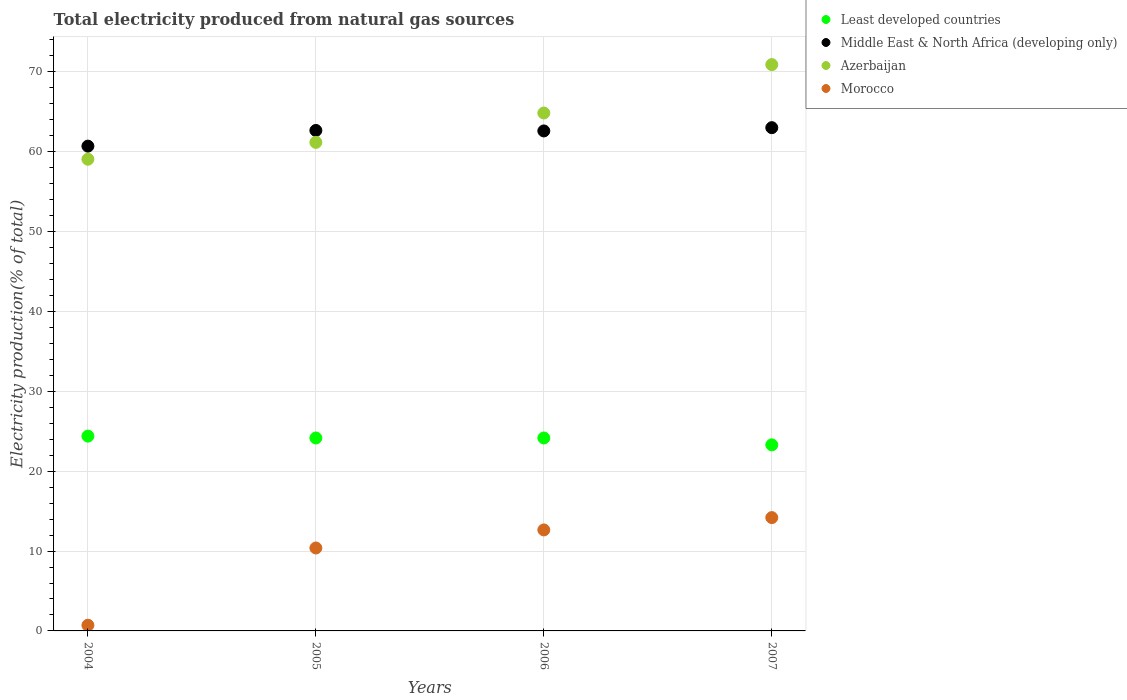What is the total electricity produced in Azerbaijan in 2007?
Keep it short and to the point. 70.91. Across all years, what is the maximum total electricity produced in Least developed countries?
Ensure brevity in your answer.  24.39. Across all years, what is the minimum total electricity produced in Middle East & North Africa (developing only)?
Ensure brevity in your answer.  60.7. In which year was the total electricity produced in Least developed countries maximum?
Offer a terse response. 2004. In which year was the total electricity produced in Morocco minimum?
Offer a terse response. 2004. What is the total total electricity produced in Azerbaijan in the graph?
Your answer should be very brief. 255.98. What is the difference between the total electricity produced in Azerbaijan in 2005 and that in 2006?
Your answer should be very brief. -3.67. What is the difference between the total electricity produced in Azerbaijan in 2006 and the total electricity produced in Least developed countries in 2005?
Provide a succinct answer. 40.69. What is the average total electricity produced in Middle East & North Africa (developing only) per year?
Your answer should be very brief. 62.24. In the year 2004, what is the difference between the total electricity produced in Least developed countries and total electricity produced in Morocco?
Ensure brevity in your answer.  23.68. In how many years, is the total electricity produced in Azerbaijan greater than 28 %?
Your answer should be compact. 4. What is the ratio of the total electricity produced in Middle East & North Africa (developing only) in 2004 to that in 2006?
Your response must be concise. 0.97. Is the total electricity produced in Morocco in 2005 less than that in 2006?
Offer a terse response. Yes. What is the difference between the highest and the second highest total electricity produced in Azerbaijan?
Give a very brief answer. 6.06. What is the difference between the highest and the lowest total electricity produced in Morocco?
Give a very brief answer. 13.48. In how many years, is the total electricity produced in Morocco greater than the average total electricity produced in Morocco taken over all years?
Make the answer very short. 3. Is the sum of the total electricity produced in Least developed countries in 2004 and 2007 greater than the maximum total electricity produced in Morocco across all years?
Your answer should be very brief. Yes. Is the total electricity produced in Morocco strictly greater than the total electricity produced in Azerbaijan over the years?
Offer a very short reply. No. What is the difference between two consecutive major ticks on the Y-axis?
Your answer should be compact. 10. Are the values on the major ticks of Y-axis written in scientific E-notation?
Your response must be concise. No. Does the graph contain grids?
Give a very brief answer. Yes. Where does the legend appear in the graph?
Ensure brevity in your answer.  Top right. What is the title of the graph?
Give a very brief answer. Total electricity produced from natural gas sources. What is the label or title of the X-axis?
Ensure brevity in your answer.  Years. What is the Electricity production(% of total) of Least developed countries in 2004?
Your answer should be compact. 24.39. What is the Electricity production(% of total) in Middle East & North Africa (developing only) in 2004?
Your answer should be compact. 60.7. What is the Electricity production(% of total) in Azerbaijan in 2004?
Make the answer very short. 59.06. What is the Electricity production(% of total) of Morocco in 2004?
Your answer should be very brief. 0.71. What is the Electricity production(% of total) in Least developed countries in 2005?
Ensure brevity in your answer.  24.16. What is the Electricity production(% of total) of Middle East & North Africa (developing only) in 2005?
Offer a terse response. 62.66. What is the Electricity production(% of total) of Azerbaijan in 2005?
Your response must be concise. 61.17. What is the Electricity production(% of total) of Morocco in 2005?
Provide a succinct answer. 10.38. What is the Electricity production(% of total) of Least developed countries in 2006?
Ensure brevity in your answer.  24.16. What is the Electricity production(% of total) in Middle East & North Africa (developing only) in 2006?
Your answer should be compact. 62.6. What is the Electricity production(% of total) in Azerbaijan in 2006?
Your answer should be compact. 64.85. What is the Electricity production(% of total) in Morocco in 2006?
Offer a very short reply. 12.65. What is the Electricity production(% of total) in Least developed countries in 2007?
Ensure brevity in your answer.  23.3. What is the Electricity production(% of total) in Middle East & North Africa (developing only) in 2007?
Your response must be concise. 63.01. What is the Electricity production(% of total) in Azerbaijan in 2007?
Ensure brevity in your answer.  70.91. What is the Electricity production(% of total) of Morocco in 2007?
Make the answer very short. 14.19. Across all years, what is the maximum Electricity production(% of total) of Least developed countries?
Your answer should be very brief. 24.39. Across all years, what is the maximum Electricity production(% of total) in Middle East & North Africa (developing only)?
Your answer should be very brief. 63.01. Across all years, what is the maximum Electricity production(% of total) of Azerbaijan?
Make the answer very short. 70.91. Across all years, what is the maximum Electricity production(% of total) in Morocco?
Your response must be concise. 14.19. Across all years, what is the minimum Electricity production(% of total) in Least developed countries?
Your answer should be compact. 23.3. Across all years, what is the minimum Electricity production(% of total) in Middle East & North Africa (developing only)?
Offer a very short reply. 60.7. Across all years, what is the minimum Electricity production(% of total) in Azerbaijan?
Offer a very short reply. 59.06. Across all years, what is the minimum Electricity production(% of total) in Morocco?
Make the answer very short. 0.71. What is the total Electricity production(% of total) of Least developed countries in the graph?
Ensure brevity in your answer.  96. What is the total Electricity production(% of total) in Middle East & North Africa (developing only) in the graph?
Keep it short and to the point. 248.97. What is the total Electricity production(% of total) in Azerbaijan in the graph?
Make the answer very short. 255.98. What is the total Electricity production(% of total) of Morocco in the graph?
Ensure brevity in your answer.  37.93. What is the difference between the Electricity production(% of total) in Least developed countries in 2004 and that in 2005?
Your response must be concise. 0.23. What is the difference between the Electricity production(% of total) of Middle East & North Africa (developing only) in 2004 and that in 2005?
Offer a terse response. -1.96. What is the difference between the Electricity production(% of total) of Azerbaijan in 2004 and that in 2005?
Provide a succinct answer. -2.11. What is the difference between the Electricity production(% of total) in Morocco in 2004 and that in 2005?
Ensure brevity in your answer.  -9.67. What is the difference between the Electricity production(% of total) of Least developed countries in 2004 and that in 2006?
Your answer should be very brief. 0.24. What is the difference between the Electricity production(% of total) in Middle East & North Africa (developing only) in 2004 and that in 2006?
Ensure brevity in your answer.  -1.9. What is the difference between the Electricity production(% of total) in Azerbaijan in 2004 and that in 2006?
Provide a succinct answer. -5.79. What is the difference between the Electricity production(% of total) of Morocco in 2004 and that in 2006?
Give a very brief answer. -11.93. What is the difference between the Electricity production(% of total) in Least developed countries in 2004 and that in 2007?
Provide a succinct answer. 1.1. What is the difference between the Electricity production(% of total) of Middle East & North Africa (developing only) in 2004 and that in 2007?
Your response must be concise. -2.31. What is the difference between the Electricity production(% of total) in Azerbaijan in 2004 and that in 2007?
Your response must be concise. -11.85. What is the difference between the Electricity production(% of total) of Morocco in 2004 and that in 2007?
Keep it short and to the point. -13.48. What is the difference between the Electricity production(% of total) of Least developed countries in 2005 and that in 2006?
Your response must be concise. 0. What is the difference between the Electricity production(% of total) of Middle East & North Africa (developing only) in 2005 and that in 2006?
Make the answer very short. 0.06. What is the difference between the Electricity production(% of total) in Azerbaijan in 2005 and that in 2006?
Offer a terse response. -3.67. What is the difference between the Electricity production(% of total) in Morocco in 2005 and that in 2006?
Your answer should be very brief. -2.26. What is the difference between the Electricity production(% of total) of Least developed countries in 2005 and that in 2007?
Provide a succinct answer. 0.86. What is the difference between the Electricity production(% of total) in Middle East & North Africa (developing only) in 2005 and that in 2007?
Offer a very short reply. -0.35. What is the difference between the Electricity production(% of total) in Azerbaijan in 2005 and that in 2007?
Offer a very short reply. -9.74. What is the difference between the Electricity production(% of total) of Morocco in 2005 and that in 2007?
Offer a terse response. -3.8. What is the difference between the Electricity production(% of total) of Least developed countries in 2006 and that in 2007?
Ensure brevity in your answer.  0.86. What is the difference between the Electricity production(% of total) in Middle East & North Africa (developing only) in 2006 and that in 2007?
Your response must be concise. -0.41. What is the difference between the Electricity production(% of total) in Azerbaijan in 2006 and that in 2007?
Provide a short and direct response. -6.06. What is the difference between the Electricity production(% of total) in Morocco in 2006 and that in 2007?
Offer a terse response. -1.54. What is the difference between the Electricity production(% of total) of Least developed countries in 2004 and the Electricity production(% of total) of Middle East & North Africa (developing only) in 2005?
Provide a succinct answer. -38.27. What is the difference between the Electricity production(% of total) in Least developed countries in 2004 and the Electricity production(% of total) in Azerbaijan in 2005?
Offer a very short reply. -36.78. What is the difference between the Electricity production(% of total) in Least developed countries in 2004 and the Electricity production(% of total) in Morocco in 2005?
Provide a short and direct response. 14.01. What is the difference between the Electricity production(% of total) of Middle East & North Africa (developing only) in 2004 and the Electricity production(% of total) of Azerbaijan in 2005?
Offer a very short reply. -0.47. What is the difference between the Electricity production(% of total) of Middle East & North Africa (developing only) in 2004 and the Electricity production(% of total) of Morocco in 2005?
Provide a short and direct response. 50.32. What is the difference between the Electricity production(% of total) of Azerbaijan in 2004 and the Electricity production(% of total) of Morocco in 2005?
Your answer should be compact. 48.68. What is the difference between the Electricity production(% of total) of Least developed countries in 2004 and the Electricity production(% of total) of Middle East & North Africa (developing only) in 2006?
Make the answer very short. -38.21. What is the difference between the Electricity production(% of total) in Least developed countries in 2004 and the Electricity production(% of total) in Azerbaijan in 2006?
Make the answer very short. -40.45. What is the difference between the Electricity production(% of total) in Least developed countries in 2004 and the Electricity production(% of total) in Morocco in 2006?
Offer a terse response. 11.75. What is the difference between the Electricity production(% of total) in Middle East & North Africa (developing only) in 2004 and the Electricity production(% of total) in Azerbaijan in 2006?
Offer a terse response. -4.15. What is the difference between the Electricity production(% of total) in Middle East & North Africa (developing only) in 2004 and the Electricity production(% of total) in Morocco in 2006?
Your answer should be very brief. 48.05. What is the difference between the Electricity production(% of total) in Azerbaijan in 2004 and the Electricity production(% of total) in Morocco in 2006?
Give a very brief answer. 46.41. What is the difference between the Electricity production(% of total) of Least developed countries in 2004 and the Electricity production(% of total) of Middle East & North Africa (developing only) in 2007?
Provide a succinct answer. -38.62. What is the difference between the Electricity production(% of total) in Least developed countries in 2004 and the Electricity production(% of total) in Azerbaijan in 2007?
Offer a very short reply. -46.51. What is the difference between the Electricity production(% of total) of Least developed countries in 2004 and the Electricity production(% of total) of Morocco in 2007?
Offer a very short reply. 10.2. What is the difference between the Electricity production(% of total) in Middle East & North Africa (developing only) in 2004 and the Electricity production(% of total) in Azerbaijan in 2007?
Keep it short and to the point. -10.21. What is the difference between the Electricity production(% of total) of Middle East & North Africa (developing only) in 2004 and the Electricity production(% of total) of Morocco in 2007?
Keep it short and to the point. 46.51. What is the difference between the Electricity production(% of total) of Azerbaijan in 2004 and the Electricity production(% of total) of Morocco in 2007?
Ensure brevity in your answer.  44.87. What is the difference between the Electricity production(% of total) of Least developed countries in 2005 and the Electricity production(% of total) of Middle East & North Africa (developing only) in 2006?
Provide a short and direct response. -38.44. What is the difference between the Electricity production(% of total) of Least developed countries in 2005 and the Electricity production(% of total) of Azerbaijan in 2006?
Provide a short and direct response. -40.69. What is the difference between the Electricity production(% of total) of Least developed countries in 2005 and the Electricity production(% of total) of Morocco in 2006?
Provide a short and direct response. 11.51. What is the difference between the Electricity production(% of total) of Middle East & North Africa (developing only) in 2005 and the Electricity production(% of total) of Azerbaijan in 2006?
Ensure brevity in your answer.  -2.18. What is the difference between the Electricity production(% of total) of Middle East & North Africa (developing only) in 2005 and the Electricity production(% of total) of Morocco in 2006?
Provide a short and direct response. 50.02. What is the difference between the Electricity production(% of total) in Azerbaijan in 2005 and the Electricity production(% of total) in Morocco in 2006?
Your response must be concise. 48.52. What is the difference between the Electricity production(% of total) of Least developed countries in 2005 and the Electricity production(% of total) of Middle East & North Africa (developing only) in 2007?
Ensure brevity in your answer.  -38.85. What is the difference between the Electricity production(% of total) in Least developed countries in 2005 and the Electricity production(% of total) in Azerbaijan in 2007?
Make the answer very short. -46.75. What is the difference between the Electricity production(% of total) in Least developed countries in 2005 and the Electricity production(% of total) in Morocco in 2007?
Offer a very short reply. 9.97. What is the difference between the Electricity production(% of total) of Middle East & North Africa (developing only) in 2005 and the Electricity production(% of total) of Azerbaijan in 2007?
Provide a short and direct response. -8.24. What is the difference between the Electricity production(% of total) in Middle East & North Africa (developing only) in 2005 and the Electricity production(% of total) in Morocco in 2007?
Give a very brief answer. 48.47. What is the difference between the Electricity production(% of total) in Azerbaijan in 2005 and the Electricity production(% of total) in Morocco in 2007?
Your response must be concise. 46.98. What is the difference between the Electricity production(% of total) of Least developed countries in 2006 and the Electricity production(% of total) of Middle East & North Africa (developing only) in 2007?
Ensure brevity in your answer.  -38.85. What is the difference between the Electricity production(% of total) of Least developed countries in 2006 and the Electricity production(% of total) of Azerbaijan in 2007?
Keep it short and to the point. -46.75. What is the difference between the Electricity production(% of total) in Least developed countries in 2006 and the Electricity production(% of total) in Morocco in 2007?
Keep it short and to the point. 9.97. What is the difference between the Electricity production(% of total) of Middle East & North Africa (developing only) in 2006 and the Electricity production(% of total) of Azerbaijan in 2007?
Make the answer very short. -8.31. What is the difference between the Electricity production(% of total) of Middle East & North Africa (developing only) in 2006 and the Electricity production(% of total) of Morocco in 2007?
Provide a succinct answer. 48.41. What is the difference between the Electricity production(% of total) of Azerbaijan in 2006 and the Electricity production(% of total) of Morocco in 2007?
Offer a terse response. 50.66. What is the average Electricity production(% of total) of Least developed countries per year?
Provide a succinct answer. 24. What is the average Electricity production(% of total) in Middle East & North Africa (developing only) per year?
Keep it short and to the point. 62.24. What is the average Electricity production(% of total) of Azerbaijan per year?
Your answer should be very brief. 64. What is the average Electricity production(% of total) of Morocco per year?
Give a very brief answer. 9.48. In the year 2004, what is the difference between the Electricity production(% of total) in Least developed countries and Electricity production(% of total) in Middle East & North Africa (developing only)?
Offer a very short reply. -36.31. In the year 2004, what is the difference between the Electricity production(% of total) of Least developed countries and Electricity production(% of total) of Azerbaijan?
Provide a short and direct response. -34.67. In the year 2004, what is the difference between the Electricity production(% of total) of Least developed countries and Electricity production(% of total) of Morocco?
Give a very brief answer. 23.68. In the year 2004, what is the difference between the Electricity production(% of total) in Middle East & North Africa (developing only) and Electricity production(% of total) in Azerbaijan?
Provide a succinct answer. 1.64. In the year 2004, what is the difference between the Electricity production(% of total) of Middle East & North Africa (developing only) and Electricity production(% of total) of Morocco?
Provide a short and direct response. 59.99. In the year 2004, what is the difference between the Electricity production(% of total) in Azerbaijan and Electricity production(% of total) in Morocco?
Ensure brevity in your answer.  58.35. In the year 2005, what is the difference between the Electricity production(% of total) of Least developed countries and Electricity production(% of total) of Middle East & North Africa (developing only)?
Give a very brief answer. -38.5. In the year 2005, what is the difference between the Electricity production(% of total) of Least developed countries and Electricity production(% of total) of Azerbaijan?
Provide a succinct answer. -37.01. In the year 2005, what is the difference between the Electricity production(% of total) in Least developed countries and Electricity production(% of total) in Morocco?
Provide a succinct answer. 13.77. In the year 2005, what is the difference between the Electricity production(% of total) of Middle East & North Africa (developing only) and Electricity production(% of total) of Azerbaijan?
Your response must be concise. 1.49. In the year 2005, what is the difference between the Electricity production(% of total) in Middle East & North Africa (developing only) and Electricity production(% of total) in Morocco?
Your answer should be compact. 52.28. In the year 2005, what is the difference between the Electricity production(% of total) of Azerbaijan and Electricity production(% of total) of Morocco?
Make the answer very short. 50.79. In the year 2006, what is the difference between the Electricity production(% of total) of Least developed countries and Electricity production(% of total) of Middle East & North Africa (developing only)?
Your answer should be very brief. -38.44. In the year 2006, what is the difference between the Electricity production(% of total) in Least developed countries and Electricity production(% of total) in Azerbaijan?
Give a very brief answer. -40.69. In the year 2006, what is the difference between the Electricity production(% of total) of Least developed countries and Electricity production(% of total) of Morocco?
Offer a very short reply. 11.51. In the year 2006, what is the difference between the Electricity production(% of total) in Middle East & North Africa (developing only) and Electricity production(% of total) in Azerbaijan?
Offer a very short reply. -2.24. In the year 2006, what is the difference between the Electricity production(% of total) of Middle East & North Africa (developing only) and Electricity production(% of total) of Morocco?
Offer a terse response. 49.96. In the year 2006, what is the difference between the Electricity production(% of total) in Azerbaijan and Electricity production(% of total) in Morocco?
Offer a very short reply. 52.2. In the year 2007, what is the difference between the Electricity production(% of total) in Least developed countries and Electricity production(% of total) in Middle East & North Africa (developing only)?
Keep it short and to the point. -39.72. In the year 2007, what is the difference between the Electricity production(% of total) in Least developed countries and Electricity production(% of total) in Azerbaijan?
Offer a terse response. -47.61. In the year 2007, what is the difference between the Electricity production(% of total) of Least developed countries and Electricity production(% of total) of Morocco?
Your response must be concise. 9.11. In the year 2007, what is the difference between the Electricity production(% of total) of Middle East & North Africa (developing only) and Electricity production(% of total) of Azerbaijan?
Keep it short and to the point. -7.9. In the year 2007, what is the difference between the Electricity production(% of total) of Middle East & North Africa (developing only) and Electricity production(% of total) of Morocco?
Your answer should be very brief. 48.82. In the year 2007, what is the difference between the Electricity production(% of total) of Azerbaijan and Electricity production(% of total) of Morocco?
Provide a short and direct response. 56.72. What is the ratio of the Electricity production(% of total) of Least developed countries in 2004 to that in 2005?
Keep it short and to the point. 1.01. What is the ratio of the Electricity production(% of total) in Middle East & North Africa (developing only) in 2004 to that in 2005?
Your answer should be compact. 0.97. What is the ratio of the Electricity production(% of total) in Azerbaijan in 2004 to that in 2005?
Your answer should be compact. 0.97. What is the ratio of the Electricity production(% of total) in Morocco in 2004 to that in 2005?
Your response must be concise. 0.07. What is the ratio of the Electricity production(% of total) in Least developed countries in 2004 to that in 2006?
Make the answer very short. 1.01. What is the ratio of the Electricity production(% of total) of Middle East & North Africa (developing only) in 2004 to that in 2006?
Your answer should be very brief. 0.97. What is the ratio of the Electricity production(% of total) in Azerbaijan in 2004 to that in 2006?
Offer a terse response. 0.91. What is the ratio of the Electricity production(% of total) of Morocco in 2004 to that in 2006?
Provide a succinct answer. 0.06. What is the ratio of the Electricity production(% of total) of Least developed countries in 2004 to that in 2007?
Give a very brief answer. 1.05. What is the ratio of the Electricity production(% of total) in Middle East & North Africa (developing only) in 2004 to that in 2007?
Provide a short and direct response. 0.96. What is the ratio of the Electricity production(% of total) in Azerbaijan in 2004 to that in 2007?
Offer a terse response. 0.83. What is the ratio of the Electricity production(% of total) in Morocco in 2004 to that in 2007?
Your answer should be very brief. 0.05. What is the ratio of the Electricity production(% of total) of Azerbaijan in 2005 to that in 2006?
Provide a short and direct response. 0.94. What is the ratio of the Electricity production(% of total) in Morocco in 2005 to that in 2006?
Ensure brevity in your answer.  0.82. What is the ratio of the Electricity production(% of total) of Middle East & North Africa (developing only) in 2005 to that in 2007?
Your answer should be very brief. 0.99. What is the ratio of the Electricity production(% of total) of Azerbaijan in 2005 to that in 2007?
Keep it short and to the point. 0.86. What is the ratio of the Electricity production(% of total) in Morocco in 2005 to that in 2007?
Make the answer very short. 0.73. What is the ratio of the Electricity production(% of total) in Least developed countries in 2006 to that in 2007?
Offer a terse response. 1.04. What is the ratio of the Electricity production(% of total) of Middle East & North Africa (developing only) in 2006 to that in 2007?
Ensure brevity in your answer.  0.99. What is the ratio of the Electricity production(% of total) of Azerbaijan in 2006 to that in 2007?
Provide a short and direct response. 0.91. What is the ratio of the Electricity production(% of total) of Morocco in 2006 to that in 2007?
Offer a very short reply. 0.89. What is the difference between the highest and the second highest Electricity production(% of total) in Least developed countries?
Keep it short and to the point. 0.23. What is the difference between the highest and the second highest Electricity production(% of total) of Middle East & North Africa (developing only)?
Provide a succinct answer. 0.35. What is the difference between the highest and the second highest Electricity production(% of total) in Azerbaijan?
Provide a short and direct response. 6.06. What is the difference between the highest and the second highest Electricity production(% of total) in Morocco?
Give a very brief answer. 1.54. What is the difference between the highest and the lowest Electricity production(% of total) of Least developed countries?
Provide a short and direct response. 1.1. What is the difference between the highest and the lowest Electricity production(% of total) of Middle East & North Africa (developing only)?
Give a very brief answer. 2.31. What is the difference between the highest and the lowest Electricity production(% of total) of Azerbaijan?
Your answer should be very brief. 11.85. What is the difference between the highest and the lowest Electricity production(% of total) in Morocco?
Ensure brevity in your answer.  13.48. 